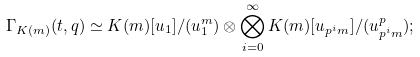Convert formula to latex. <formula><loc_0><loc_0><loc_500><loc_500>\Gamma _ { K ( m ) } ( t , q ) \simeq K ( m ) [ u _ { 1 } ] / ( u _ { 1 } ^ { m } ) \otimes \bigotimes _ { i = 0 } ^ { \infty } K ( m ) [ u _ { p ^ { i } m } ] / ( u _ { p ^ { i } m } ^ { p } ) ;</formula> 